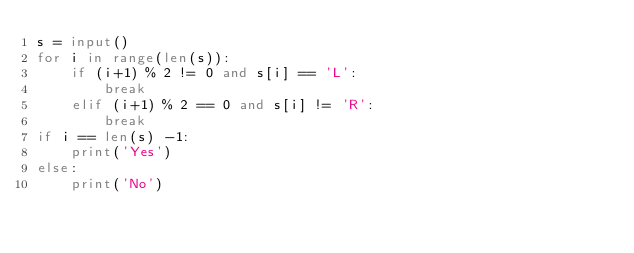Convert code to text. <code><loc_0><loc_0><loc_500><loc_500><_Python_>s = input()
for i in range(len(s)):
    if (i+1) % 2 != 0 and s[i] == 'L':
        break
    elif (i+1) % 2 == 0 and s[i] != 'R':
        break
if i == len(s) -1:
    print('Yes')
else:
    print('No') </code> 